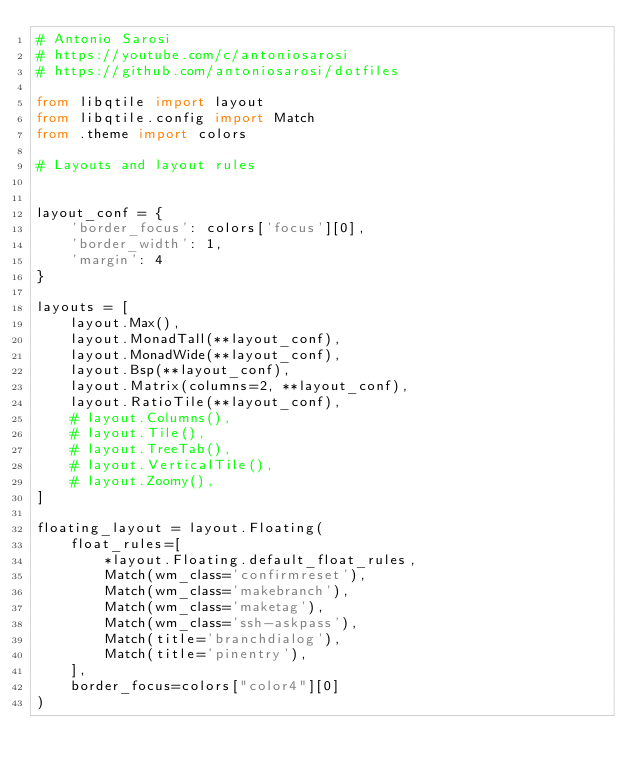<code> <loc_0><loc_0><loc_500><loc_500><_Python_># Antonio Sarosi
# https://youtube.com/c/antoniosarosi
# https://github.com/antoniosarosi/dotfiles

from libqtile import layout
from libqtile.config import Match
from .theme import colors

# Layouts and layout rules


layout_conf = {
    'border_focus': colors['focus'][0],
    'border_width': 1,
    'margin': 4
}

layouts = [
    layout.Max(),
    layout.MonadTall(**layout_conf),
    layout.MonadWide(**layout_conf),
    layout.Bsp(**layout_conf),
    layout.Matrix(columns=2, **layout_conf),
    layout.RatioTile(**layout_conf),
    # layout.Columns(),
    # layout.Tile(),
    # layout.TreeTab(),
    # layout.VerticalTile(),
    # layout.Zoomy(),
]

floating_layout = layout.Floating(
    float_rules=[
        *layout.Floating.default_float_rules,
        Match(wm_class='confirmreset'),
        Match(wm_class='makebranch'),
        Match(wm_class='maketag'),
        Match(wm_class='ssh-askpass'),
        Match(title='branchdialog'),
        Match(title='pinentry'),
    ],
    border_focus=colors["color4"][0]
)
</code> 